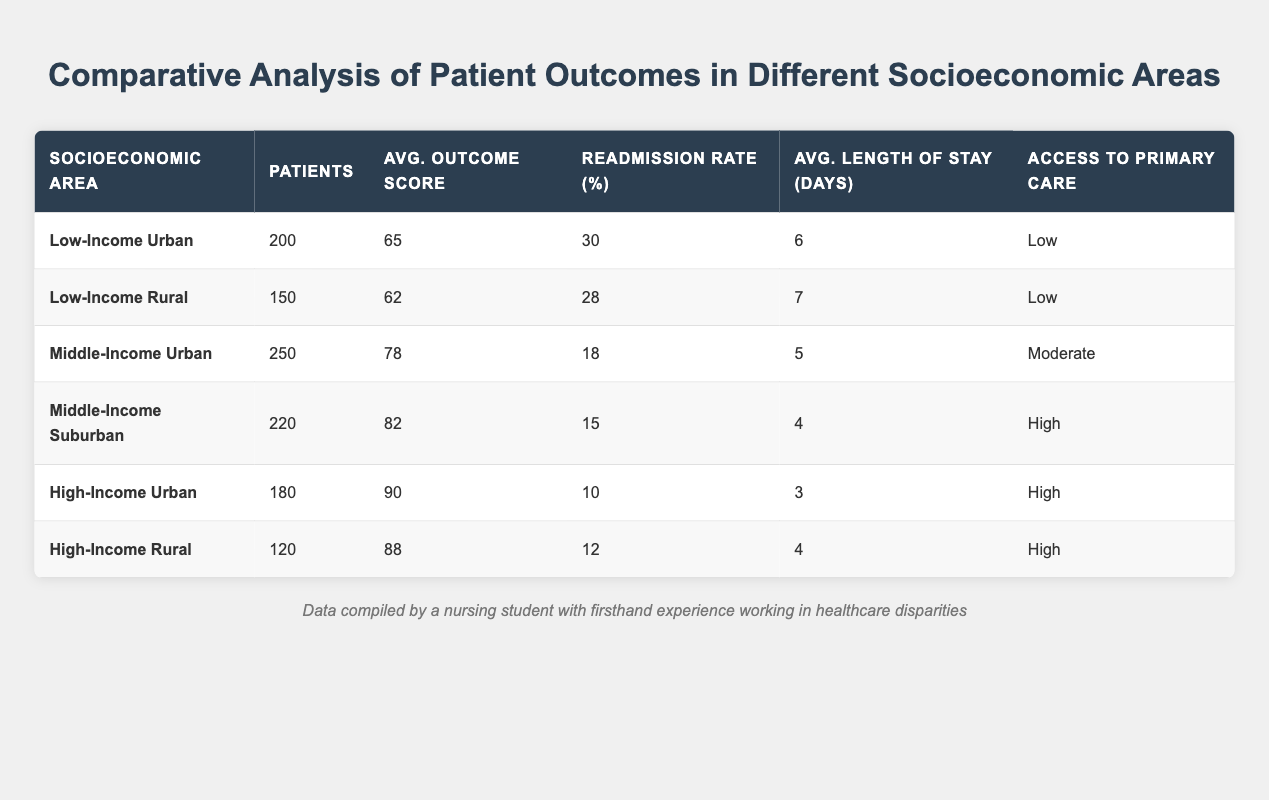What is the average outcome score for the Middle-Income Suburban area? According to the table, the average outcome score for the Middle-Income Suburban area is 82.
Answer: 82 How many patients were recorded in the Low-Income Urban area? The table indicates there were 200 patients in the Low-Income Urban area.
Answer: 200 What is the readmission rate for the High-Income Urban area? The readmission rate for the High-Income Urban area is given as 10%.
Answer: 10% Which socioeconomic area has the highest average length of stay? From the table, the Low-Income Rural area has the highest average length of stay at 7 days.
Answer: Low-Income Rural What is the average readmission rate across all areas? The total readmission rates are 30, 28, 18, 15, 10, and 12. Adding these gives 113, and with 6 areas, the average is 113/6 = 18.83%.
Answer: 18.83% Is the access to primary care for the High-Income Rural area considered low? The table states that access to primary care for the High-Income Rural area is high, so the statement is false.
Answer: No What is the difference in average outcome scores between Low-Income Urban and High-Income Urban areas? The average outcome score for Low-Income Urban is 65, while for High-Income Urban, it is 90. The difference is 90 - 65 = 25.
Answer: 25 How many more patients were treated in the Middle-Income Urban area compared to the Low-Income Rural area? The Middle-Income Urban area had 250 patients, while the Low-Income Rural area had 150 patients. The difference is 250 - 150 = 100 patients.
Answer: 100 patients Which socioeconomic area has the lowest access to primary care? The table shows that both Low-Income Urban and Low-Income Rural areas have low access to primary care, making them the areas with the lowest access.
Answer: Low-Income Urban and Low-Income Rural What is the median average outcome score of all areas listed? The average outcome scores in order are 62, 65, 78, 82, 88, and 90. The median (average of the two middle values) is (78 + 82)/2 = 80.
Answer: 80 